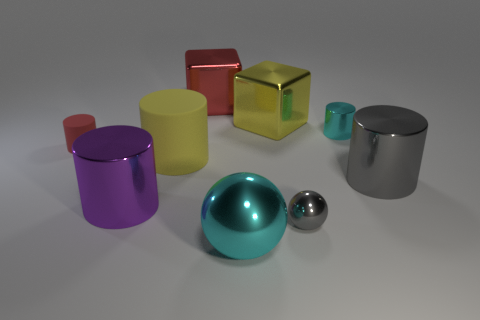There is a purple shiny thing; are there any small cyan objects in front of it?
Keep it short and to the point. No. What material is the yellow object that is right of the yellow object that is in front of the small rubber object made of?
Offer a very short reply. Metal. The red thing that is the same shape as the big gray thing is what size?
Make the answer very short. Small. Is the small matte thing the same color as the tiny metallic sphere?
Your response must be concise. No. What is the color of the object that is in front of the purple cylinder and behind the large cyan object?
Make the answer very short. Gray. Is the size of the rubber cylinder that is on the right side of the purple cylinder the same as the red block?
Your response must be concise. Yes. Are there any other things that have the same shape as the small cyan thing?
Offer a very short reply. Yes. Does the cyan cylinder have the same material as the big object in front of the large purple cylinder?
Provide a short and direct response. Yes. How many cyan objects are either small rubber things or rubber objects?
Offer a terse response. 0. Are any big blocks visible?
Offer a terse response. Yes. 